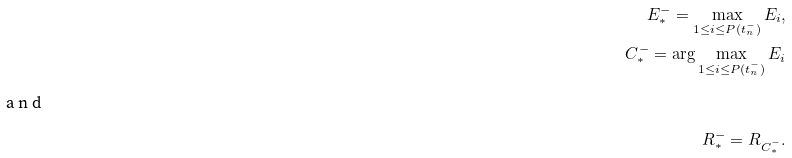<formula> <loc_0><loc_0><loc_500><loc_500>E _ { * } ^ { - } = \max _ { 1 \leq i \leq P ( t _ { n } ^ { - } ) } E _ { i } , \\ C _ { * } ^ { - } = \arg \max _ { 1 \leq i \leq P ( t _ { n } ^ { - } ) } E _ { i } \\ \intertext { a n d } R _ { * } ^ { - } = R _ { C _ { * } ^ { - } } .</formula> 